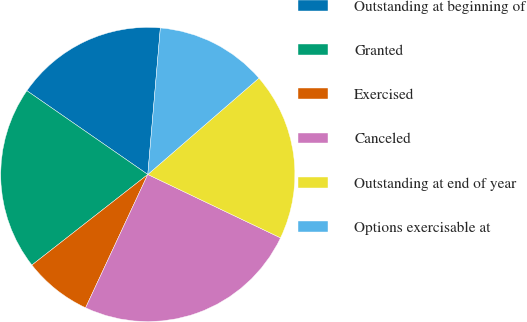Convert chart. <chart><loc_0><loc_0><loc_500><loc_500><pie_chart><fcel>Outstanding at beginning of<fcel>Granted<fcel>Exercised<fcel>Canceled<fcel>Outstanding at end of year<fcel>Options exercisable at<nl><fcel>16.72%<fcel>20.2%<fcel>7.49%<fcel>24.86%<fcel>18.46%<fcel>12.27%<nl></chart> 